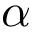<formula> <loc_0><loc_0><loc_500><loc_500>\alpha</formula> 